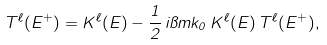<formula> <loc_0><loc_0><loc_500><loc_500>T ^ { \ell } ( E ^ { + } ) = K ^ { \ell } ( E ) - \frac { 1 } { 2 } \, i \pi m k _ { 0 } \, K ^ { \ell } ( E ) \, T ^ { \ell } ( E ^ { + } ) ,</formula> 